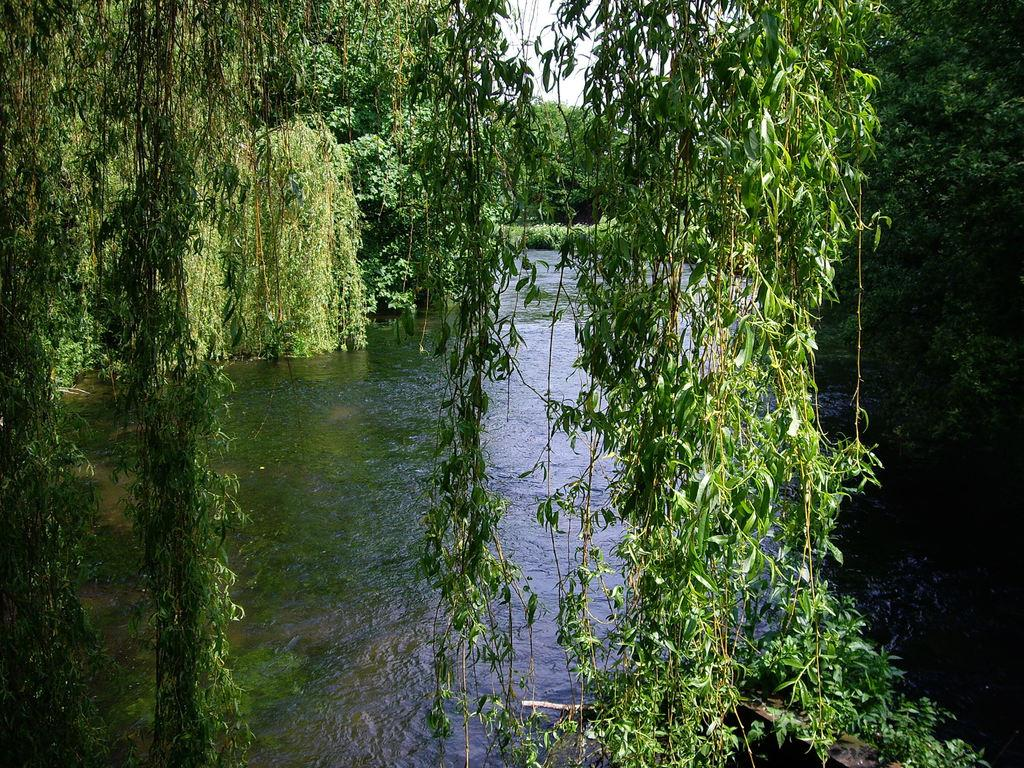What type of vegetation is visible in the image? There are trees in the image. What natural element can be seen besides the trees? There is water visible in the image. How would you describe the sky in the image? The sky appears to be cloudy in the image. How much payment is required to cross the mark in the image? There is no mark or indication of payment required in the image; it features trees and water. Can you tell me how many women are present in the image? There is no woman present in the image; it only features trees, water, and a cloudy sky. 